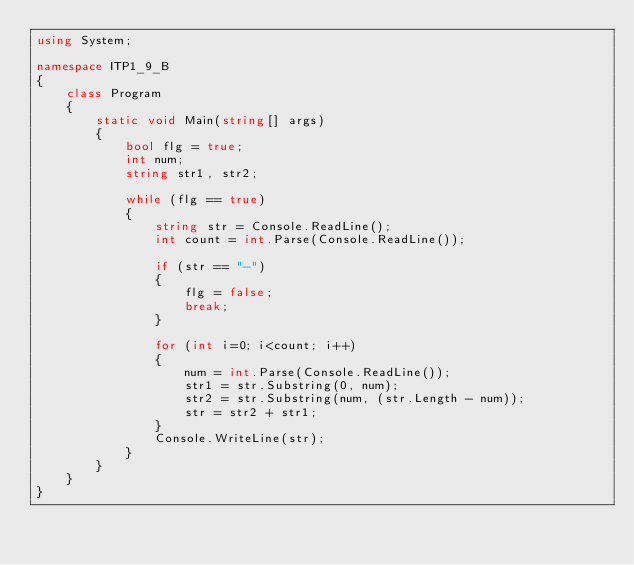<code> <loc_0><loc_0><loc_500><loc_500><_C#_>using System;

namespace ITP1_9_B
{
    class Program
    {
        static void Main(string[] args)
        {
            bool flg = true;
            int num;
            string str1, str2;

            while (flg == true)
            {
                string str = Console.ReadLine();
                int count = int.Parse(Console.ReadLine());
                
                if (str == "-")
                {
                    flg = false;
                    break;           
                }

                for (int i=0; i<count; i++)
                {
                    num = int.Parse(Console.ReadLine());
                    str1 = str.Substring(0, num);
                    str2 = str.Substring(num, (str.Length - num));
                    str = str2 + str1;
                }
                Console.WriteLine(str);            
            }
        }
    }
}</code> 